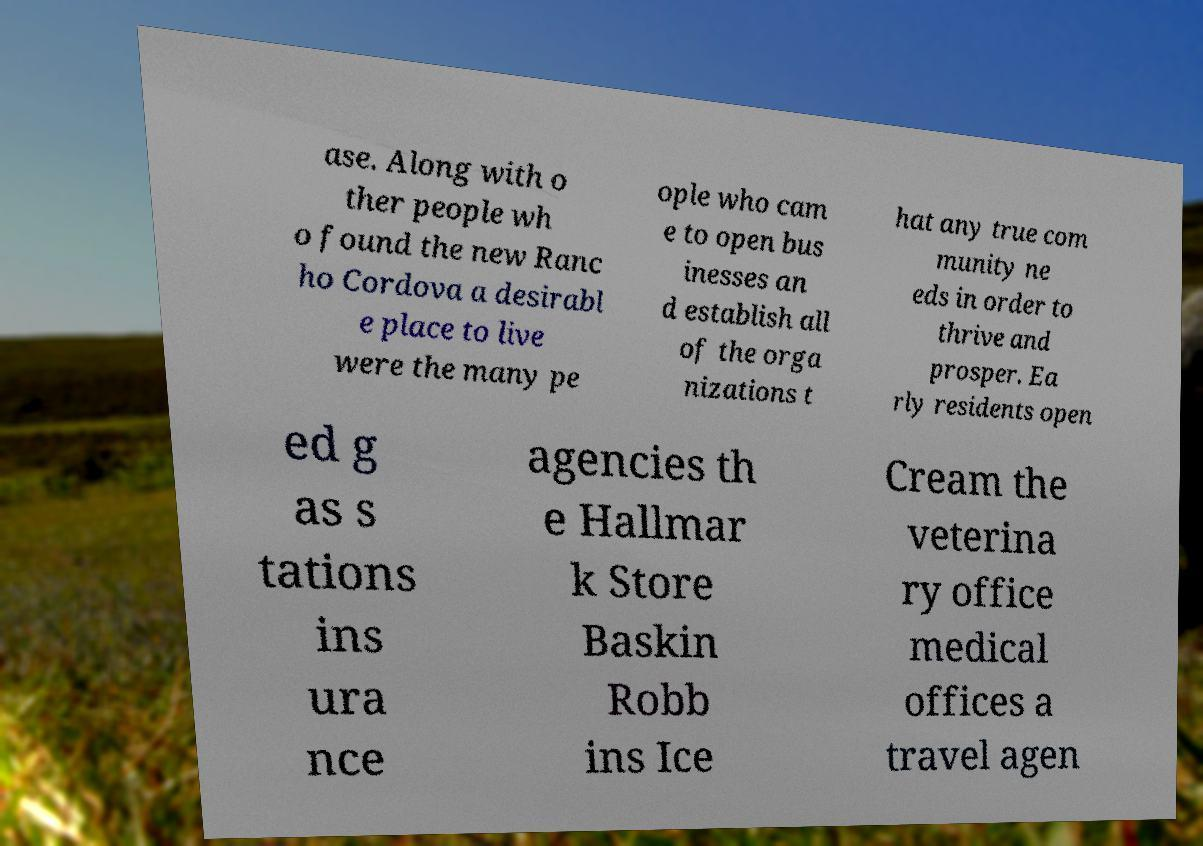Please read and relay the text visible in this image. What does it say? ase. Along with o ther people wh o found the new Ranc ho Cordova a desirabl e place to live were the many pe ople who cam e to open bus inesses an d establish all of the orga nizations t hat any true com munity ne eds in order to thrive and prosper. Ea rly residents open ed g as s tations ins ura nce agencies th e Hallmar k Store Baskin Robb ins Ice Cream the veterina ry office medical offices a travel agen 